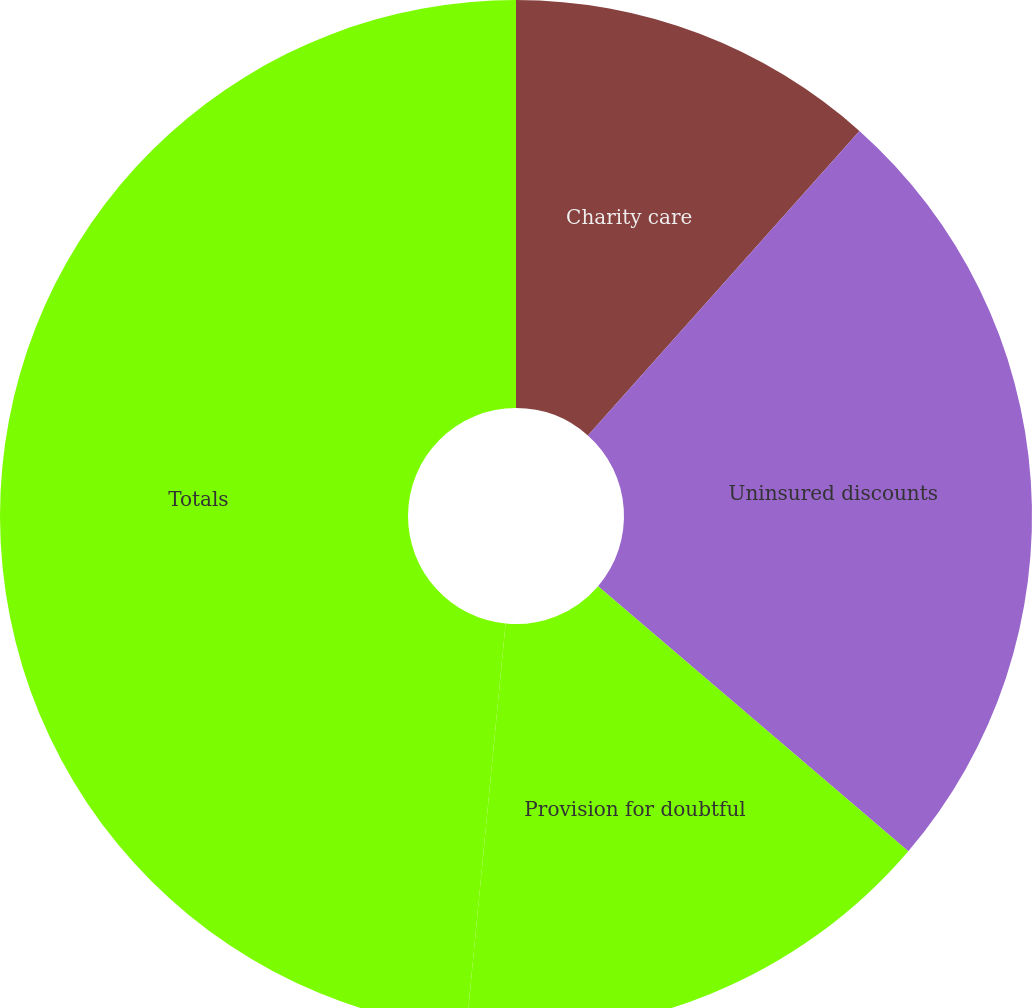Convert chart to OTSL. <chart><loc_0><loc_0><loc_500><loc_500><pie_chart><fcel>Charity care<fcel>Uninsured discounts<fcel>Provision for doubtful<fcel>Totals<nl><fcel>11.59%<fcel>24.66%<fcel>15.28%<fcel>48.46%<nl></chart> 